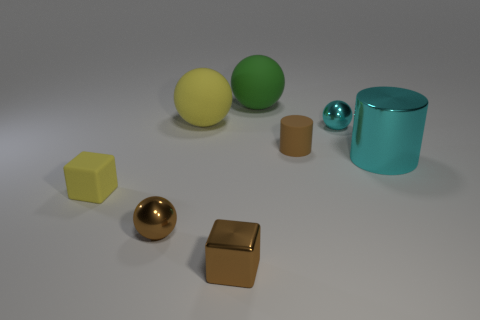Add 2 matte balls. How many objects exist? 10 Subtract all cyan cylinders. How many cylinders are left? 1 Subtract all big green spheres. How many spheres are left? 3 Subtract 0 blue balls. How many objects are left? 8 Subtract all cylinders. How many objects are left? 6 Subtract 3 spheres. How many spheres are left? 1 Subtract all purple spheres. Subtract all green cylinders. How many spheres are left? 4 Subtract all red blocks. How many brown cylinders are left? 1 Subtract all tiny brown blocks. Subtract all small brown balls. How many objects are left? 6 Add 4 brown balls. How many brown balls are left? 5 